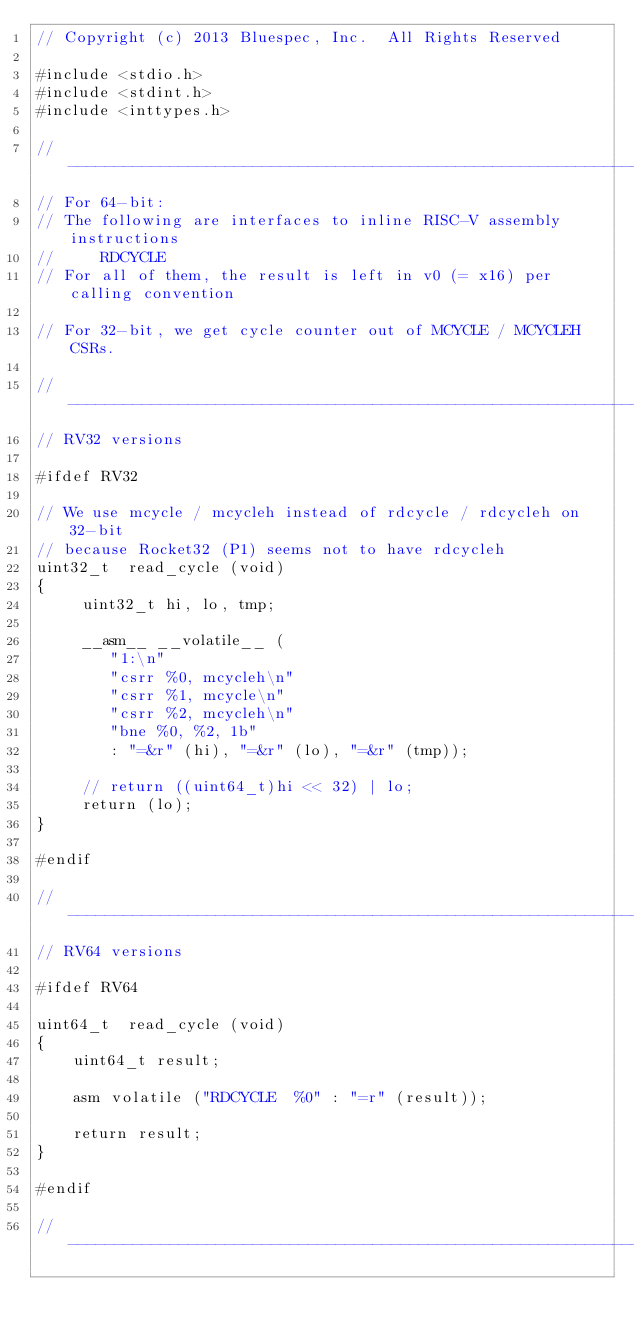Convert code to text. <code><loc_0><loc_0><loc_500><loc_500><_C_>// Copyright (c) 2013 Bluespec, Inc.  All Rights Reserved

#include <stdio.h>
#include <stdint.h>
#include <inttypes.h>

// ----------------------------------------------------------------
// For 64-bit:
// The following are interfaces to inline RISC-V assembly instructions
//     RDCYCLE
// For all of them, the result is left in v0 (= x16) per calling convention

// For 32-bit, we get cycle counter out of MCYCLE / MCYCLEH CSRs.

// ----------------------------------------------------------------
// RV32 versions

#ifdef RV32

// We use mcycle / mcycleh instead of rdcycle / rdcycleh on 32-bit
// because Rocket32 (P1) seems not to have rdcycleh
uint32_t  read_cycle (void)
{
     uint32_t hi, lo, tmp;

     __asm__ __volatile__ (
        "1:\n"
        "csrr %0, mcycleh\n"
        "csrr %1, mcycle\n"
        "csrr %2, mcycleh\n"
        "bne %0, %2, 1b"
        : "=&r" (hi), "=&r" (lo), "=&r" (tmp));

     // return ((uint64_t)hi << 32) | lo;
     return (lo);
}

#endif

// ----------------------------------------------------------------
// RV64 versions

#ifdef RV64

uint64_t  read_cycle (void)
{
    uint64_t result;

    asm volatile ("RDCYCLE  %0" : "=r" (result));

    return result;
}

#endif

// ----------------------------------------------------------------
</code> 